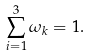<formula> <loc_0><loc_0><loc_500><loc_500>\sum _ { i = 1 } ^ { 3 } \omega _ { k } = 1 .</formula> 